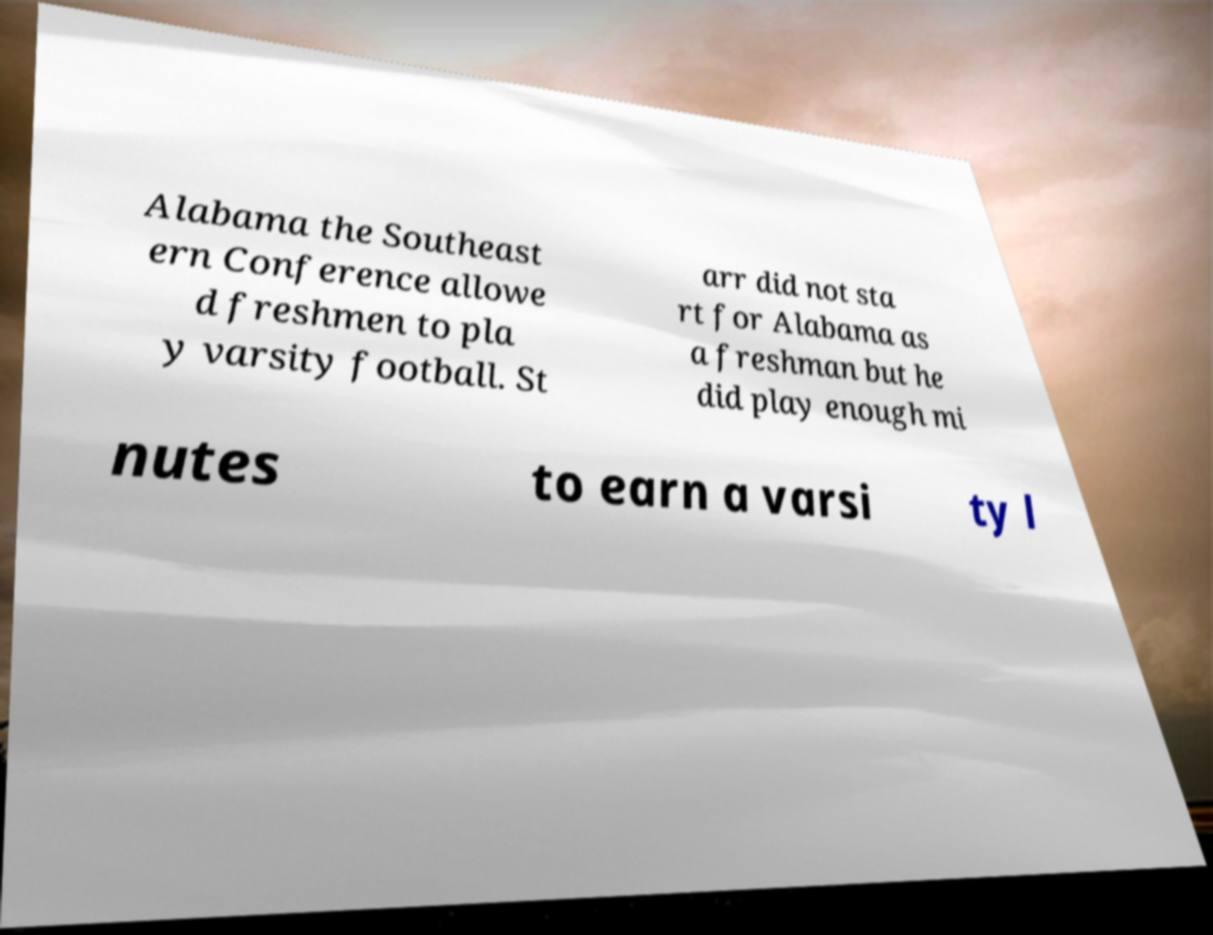Can you read and provide the text displayed in the image?This photo seems to have some interesting text. Can you extract and type it out for me? Alabama the Southeast ern Conference allowe d freshmen to pla y varsity football. St arr did not sta rt for Alabama as a freshman but he did play enough mi nutes to earn a varsi ty l 